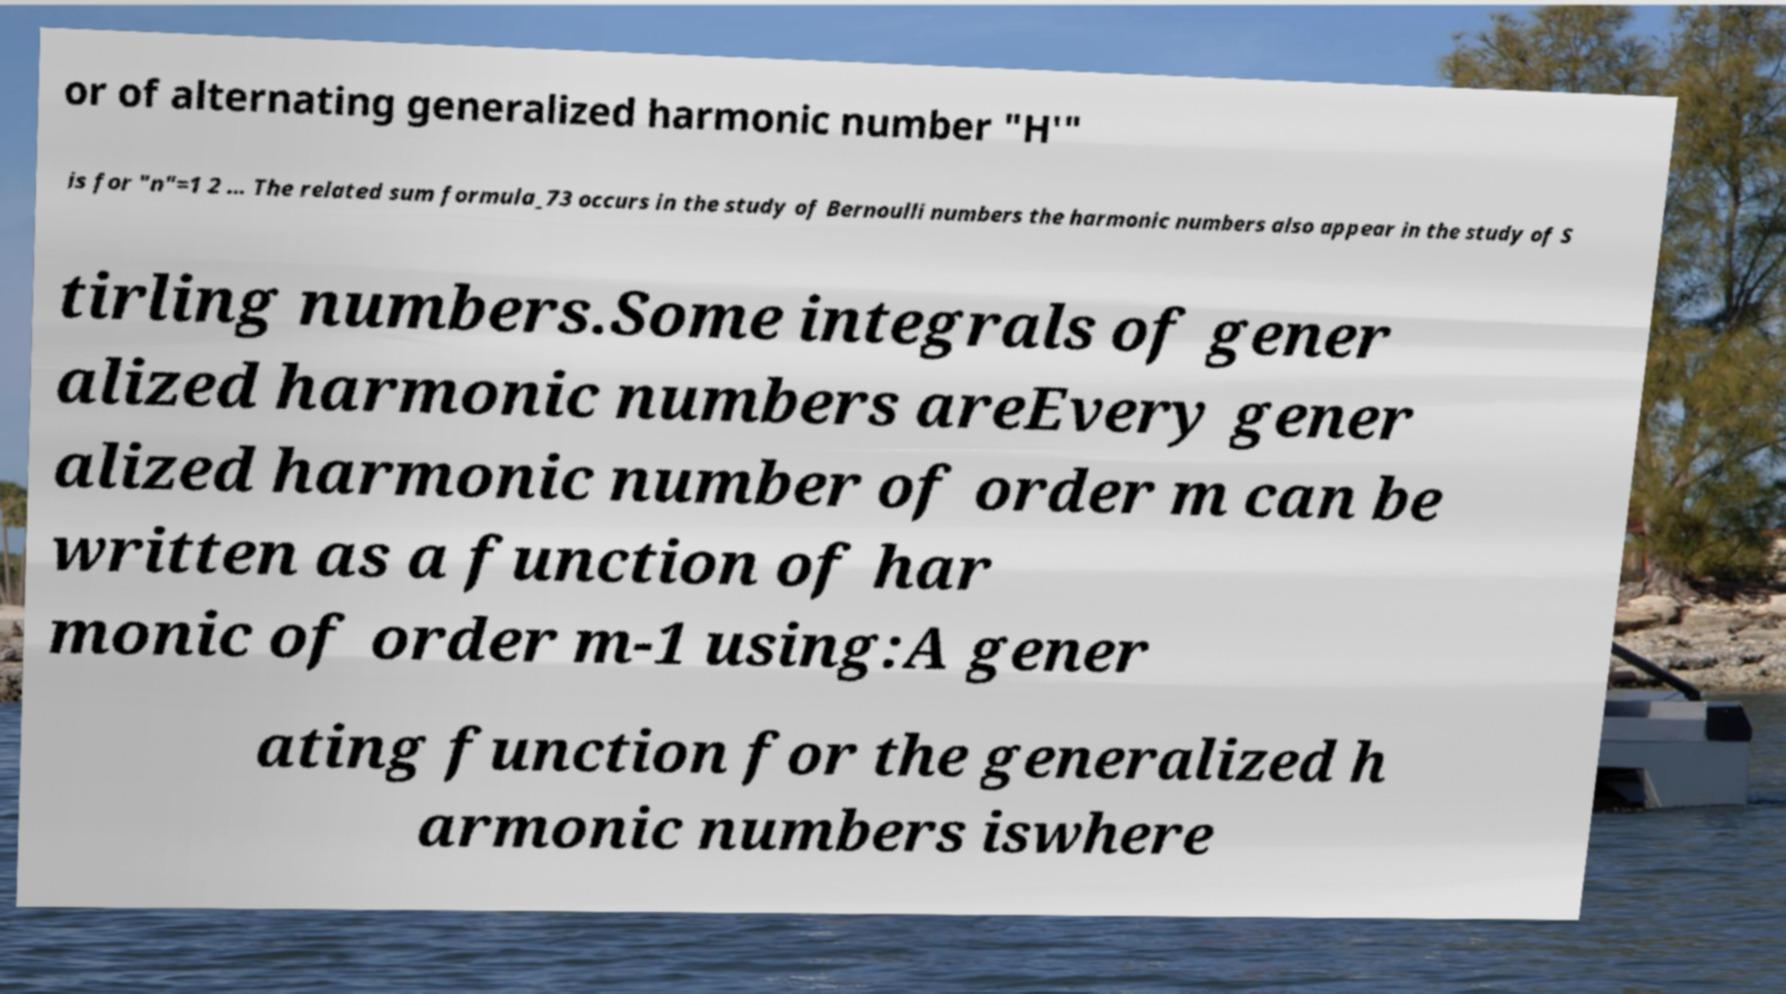Please read and relay the text visible in this image. What does it say? or of alternating generalized harmonic number "H′" is for "n"=1 2 ... The related sum formula_73 occurs in the study of Bernoulli numbers the harmonic numbers also appear in the study of S tirling numbers.Some integrals of gener alized harmonic numbers areEvery gener alized harmonic number of order m can be written as a function of har monic of order m-1 using:A gener ating function for the generalized h armonic numbers iswhere 